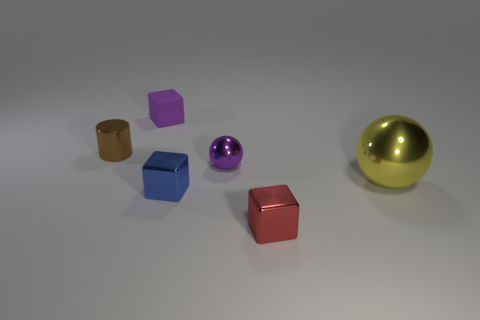Is there anything else that has the same material as the purple block?
Your answer should be very brief. No. There is a small thing that is the same color as the small rubber cube; what is it made of?
Your response must be concise. Metal. Is the big sphere behind the small red cube made of the same material as the tiny purple object that is behind the small brown metal cylinder?
Ensure brevity in your answer.  No. How many things are tiny blue cubes or objects to the left of the small rubber thing?
Your response must be concise. 2. How many yellow things have the same shape as the purple shiny thing?
Ensure brevity in your answer.  1. What material is the purple ball that is the same size as the blue shiny cube?
Keep it short and to the point. Metal. There is a shiny block to the right of the sphere behind the metal ball that is on the right side of the tiny red block; what is its size?
Make the answer very short. Small. Do the small metallic object that is on the left side of the small blue object and the tiny cube that is right of the purple shiny ball have the same color?
Offer a terse response. No. What number of purple things are tiny metal spheres or big matte things?
Keep it short and to the point. 1. What number of purple objects have the same size as the rubber cube?
Give a very brief answer. 1. 